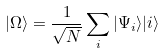<formula> <loc_0><loc_0><loc_500><loc_500>| \Omega \rangle = \frac { 1 } { \sqrt { N } } \sum _ { i } | \Psi _ { i } \rangle | i \rangle</formula> 